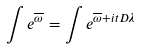Convert formula to latex. <formula><loc_0><loc_0><loc_500><loc_500>\int e ^ { \overline { \omega } } = \int e ^ { \overline { \omega } + i t D \lambda }</formula> 